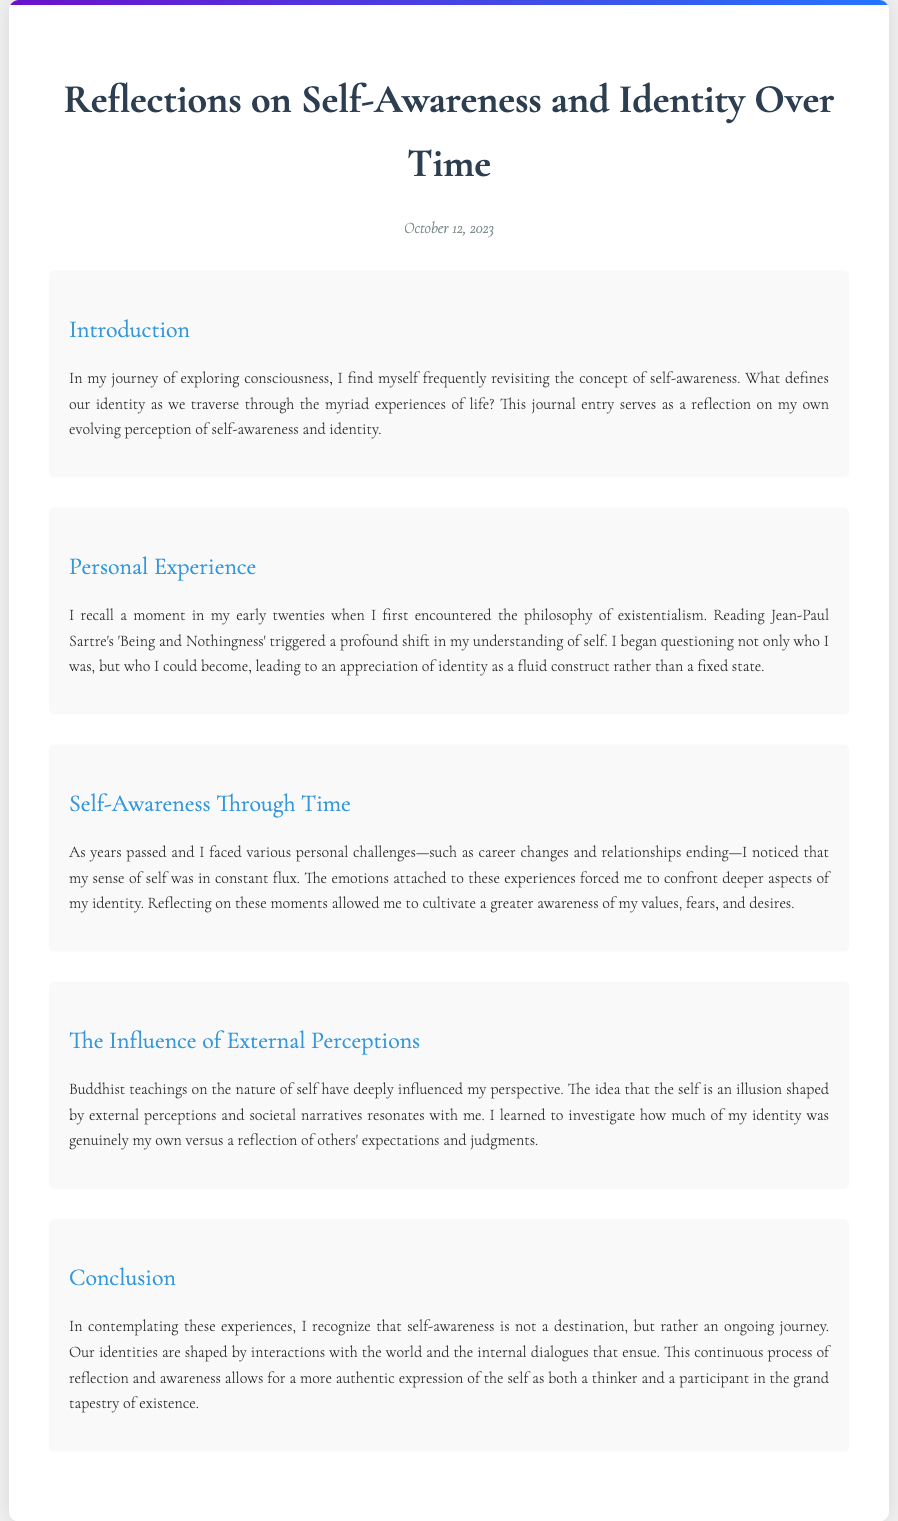What is the title of the journal entry? The title is stated at the top of the document, summarizing the main theme of reflection.
Answer: Reflections on Self-Awareness and Identity Over Time When was the journal entry written? The date is provided below the title, indicating when the reflections were recorded.
Answer: October 12, 2023 What philosophical work influenced the author in their twenties? The author mentions a specific text that catalyzed a shift in understanding of self.
Answer: Being and Nothingness Which philosophical perspective does the author reference as influencing their view of self? The author discusses a philosophy that views self as an illusion shaped by external factors.
Answer: Buddhist teachings What does the author suggest about the nature of self-awareness? The author reflects on self-awareness in the context of identity changes over time.
Answer: An ongoing journey Which author's philosophy instigated a questioning of personal identity? The author cites an influential figure whose ideas prompted deeper contemplation on identity.
Answer: Jean-Paul Sartre What two factors significantly shaped the author's self-perception over time? The author outlines experiences that contributed to their evolving sense of identity.
Answer: Personal challenges and external perceptions What is the main theme of the conclusion? The author summarizes their insights about identity and self-awareness in the closing section.
Answer: Continuous process of reflection and awareness 